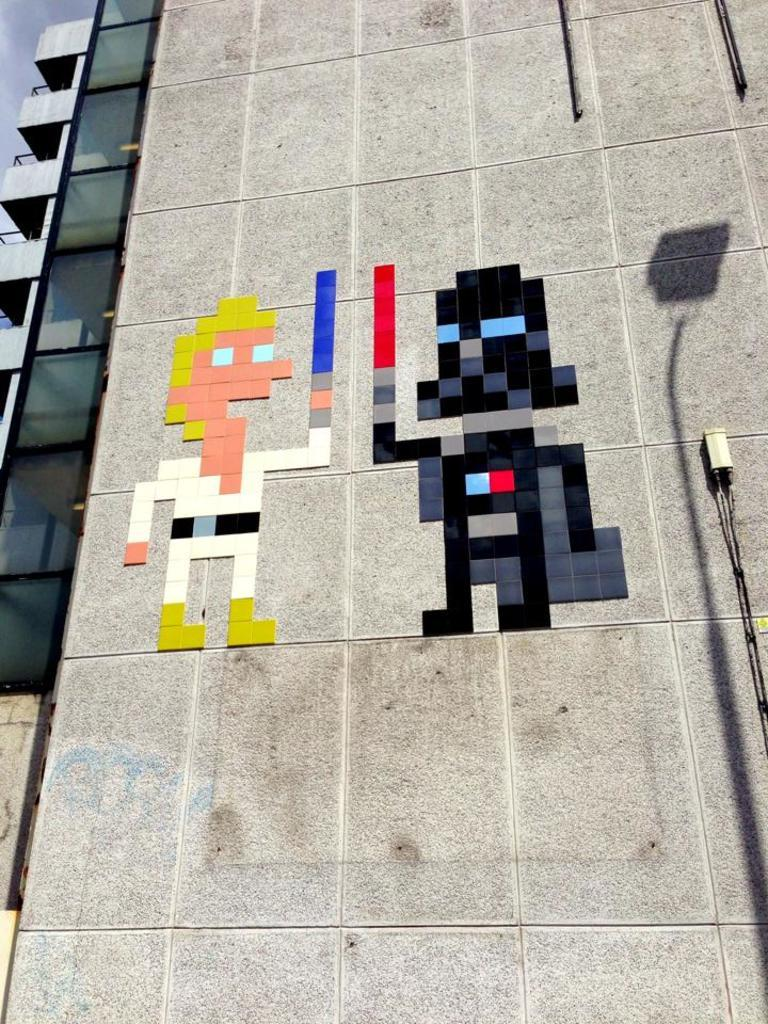What is the main structure visible in the image? There is a building in the image. Are there any decorations or signs on the building? Yes, there are posters on the building. What can be seen on the right side of the image? There is an object on the right side of the image. What type of knee injury is depicted in the image? There is no knee injury present in the image; it features a building with posters and an object on the right side. Can you describe the locket that the person in the image is wearing? There is no person wearing a locket in the image; it only shows a building, posters, and an object on the right side. 